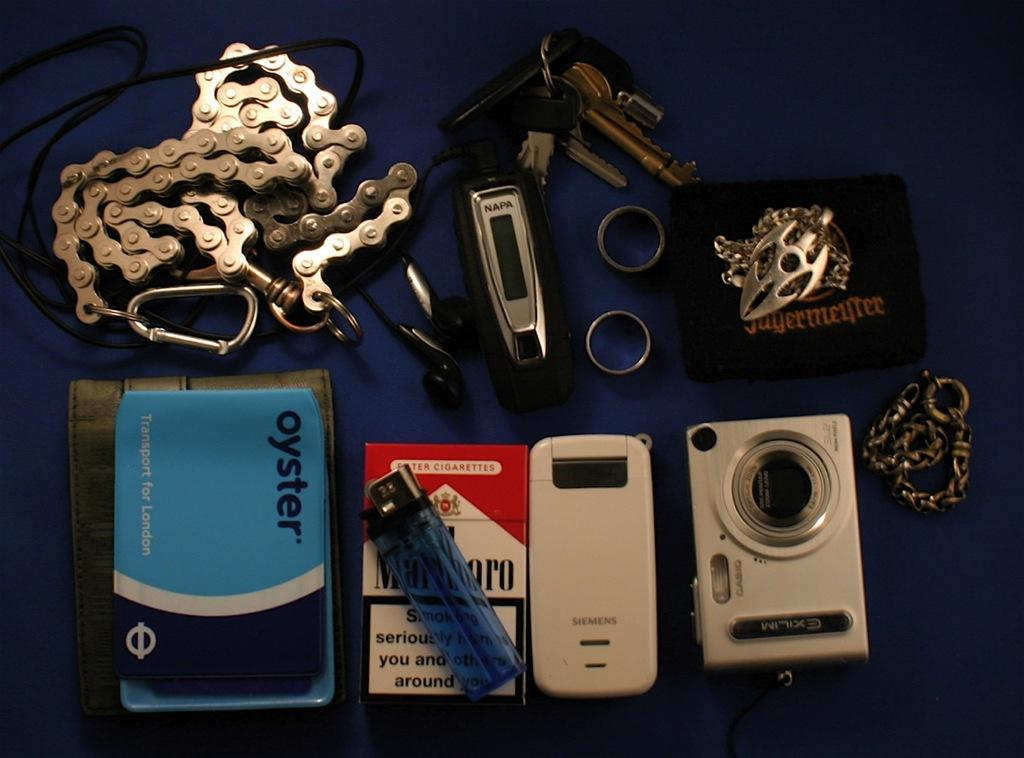What is one of the objects visible in the image? There is a book in the image. What other object can be seen in the image? There is a camera in the image. How many rings are present in the image? There are two rings in the image. What is the purpose of the keychain in the image? The keychain is one of the objects visible in the image. What color is the cloth on which the objects are placed? The objects are placed on a blue color cloth. Are there any fairies visible in the image? No, there are no fairies present in the image. What type of bath is shown in the image? There is no bath present in the image; it features a book, camera, rings, keychain, and a blue cloth. 